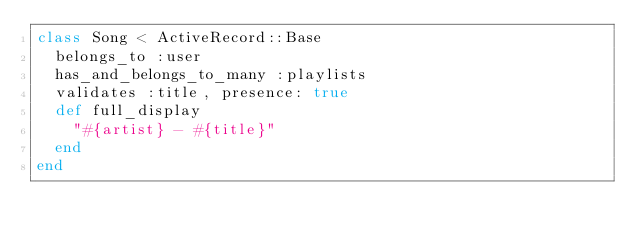<code> <loc_0><loc_0><loc_500><loc_500><_Ruby_>class Song < ActiveRecord::Base
  belongs_to :user
  has_and_belongs_to_many :playlists
  validates :title, presence: true
  def full_display
    "#{artist} - #{title}"
  end
end
</code> 